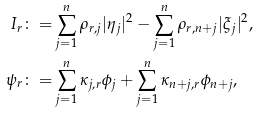Convert formula to latex. <formula><loc_0><loc_0><loc_500><loc_500>I _ { r } \colon = & \sum _ { j = 1 } ^ { n } \rho _ { r , j } | \eta _ { j } | ^ { 2 } - \sum _ { j = 1 } ^ { n } \rho _ { r , n + j } | \xi _ { j } | ^ { 2 } , \\ \psi _ { r } \colon = & \sum _ { j = 1 } ^ { n } \kappa _ { j , r } \phi _ { j } + \sum _ { j = 1 } ^ { n } \kappa _ { n + j , r } \phi _ { n + j } ,</formula> 